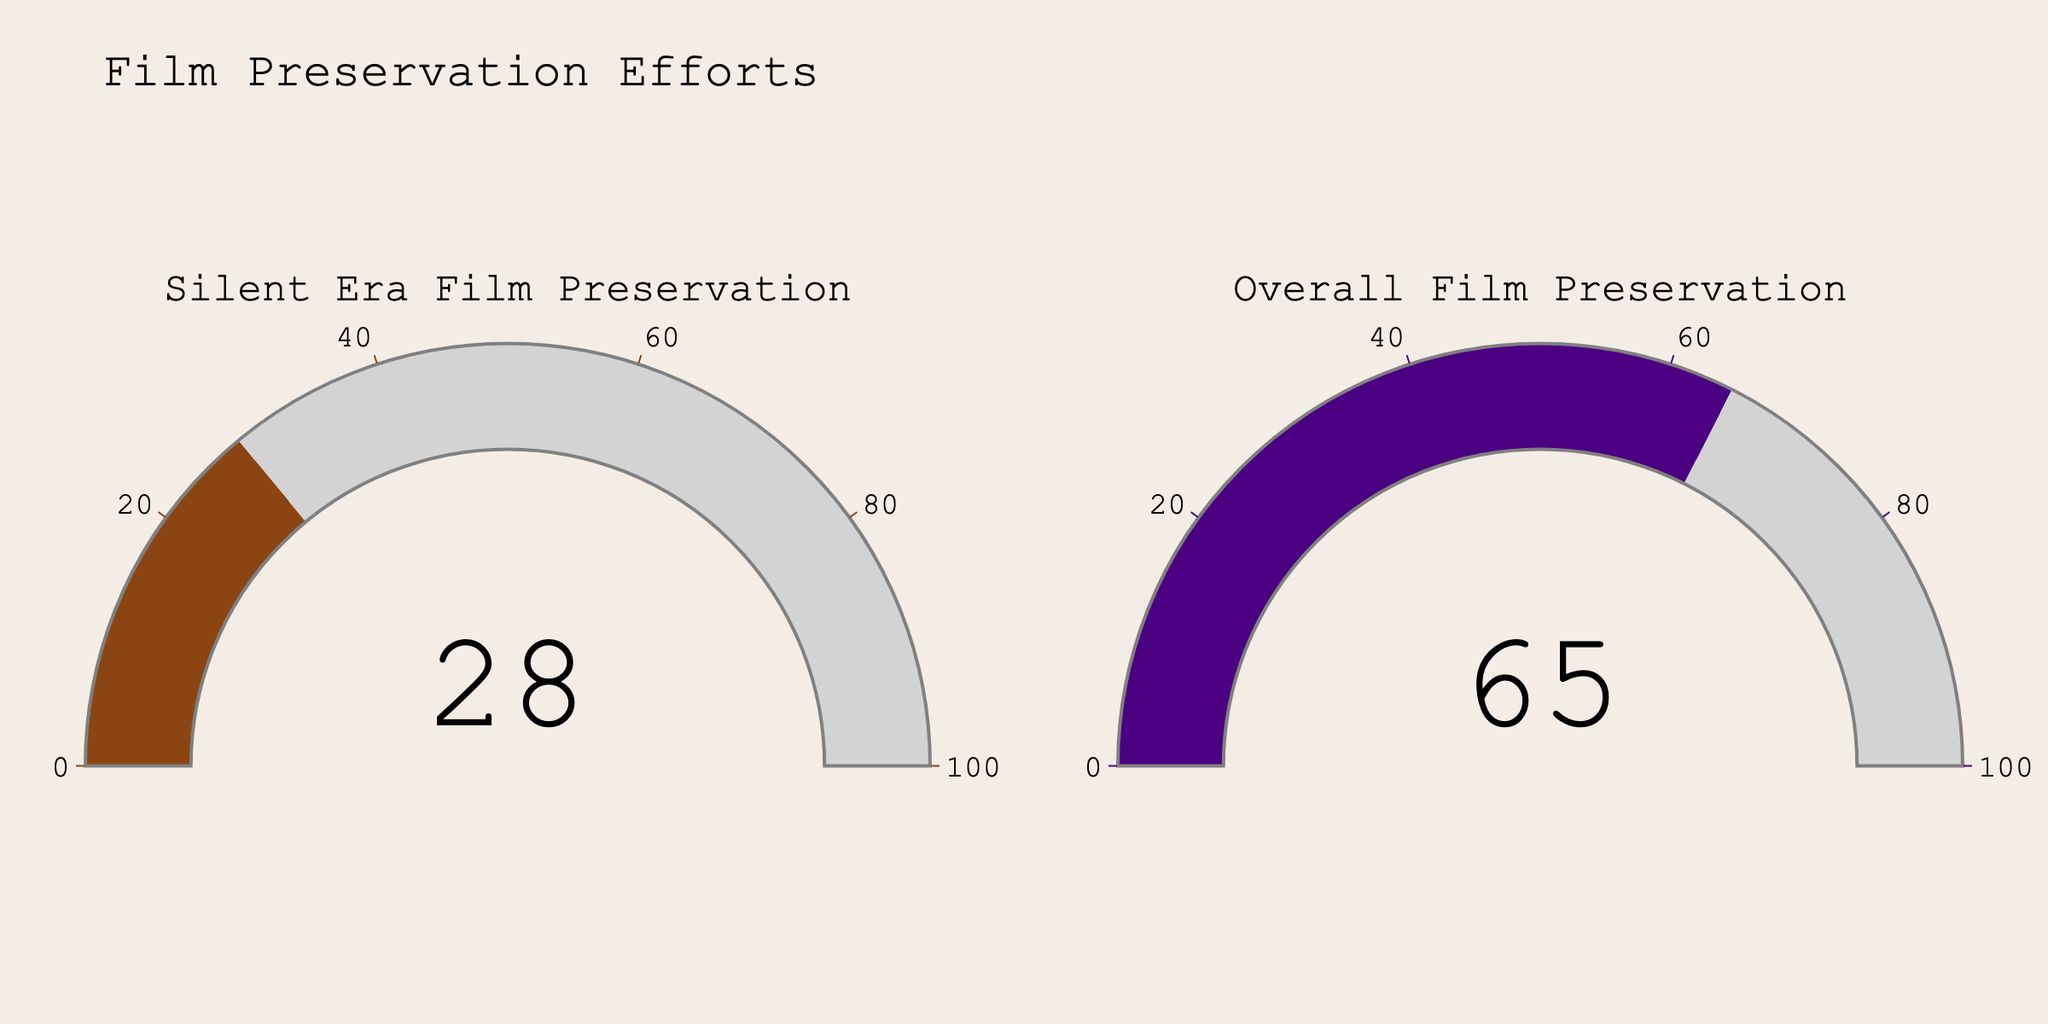What is the percentage of Silent Era Film Preservation? To find the percentage, look at the gauge labeled "Silent Era Film Preservation." The value displayed on the gauge is 28.
Answer: 28 What is the percentage of Overall Film Preservation? To find the percentage, look at the gauge labeled "Overall Film Preservation." The value displayed on the gauge is 65.
Answer: 65 What is the difference in percentages between Silent Era Film Preservation and Overall Film Preservation? Subtract the percentage of Silent Era Film Preservation (28) from the percentage of Overall Film Preservation (65). The calculation is 65 - 28.
Answer: 37 Which category has a higher preservation effort rate? Compare the percentages from both gauges. Silent Era Film Preservation is 28, and Overall Film Preservation is 65. 65 is greater, so Overall Film Preservation has a higher rate.
Answer: Overall Film Preservation By how much does the Overall Film Preservation effort exceed the Silent Era Film Preservation effort? To determine how much more the Overall Film Preservation effort exceeds, subtract the Silent Era Film Preservation percentage (28) from the Overall Film Preservation percentage (65). The result is 65 - 28.
Answer: 37 What is the sum of the preservation efforts for Silent Era and Overall films? Add the percentages from both categories. Silent Era Film Preservation is 28 and Overall Film Preservation is 65. The sum is 28 + 65.
Answer: 93 What percentage of the Overall Film Preservation does the Silent Era Film Preservation represent? Divide the Silent Era Film Preservation percentage (28) by the Overall Film Preservation percentage (65) and multiply by 100. The calculation is (28 / 65) * 100.
Answer: 43.1 What is the title of the chart? Look at the top section of the figure to find the title. The title visible is "Film Preservation Efforts."
Answer: Film Preservation Efforts What are the colors used in the gauges for Silent Era Film Preservation and Overall Film Preservation? Refer to the colors of the gauge bars. Silent Era Film Preservation uses brown, and Overall Film Preservation uses indigo.
Answer: Brown and Indigo Which gauge, Silent Era Film Preservation or Overall Film Preservation, has a larger colored segment? The gauge with the larger colored segment is given by the category with the higher percentage. The Silent Era Film Preservation gauge shows 28, while the Overall Film Preservation gauge shows 65. The gauge for Overall Film Preservation has the larger colored segment.
Answer: Overall Film Preservation 